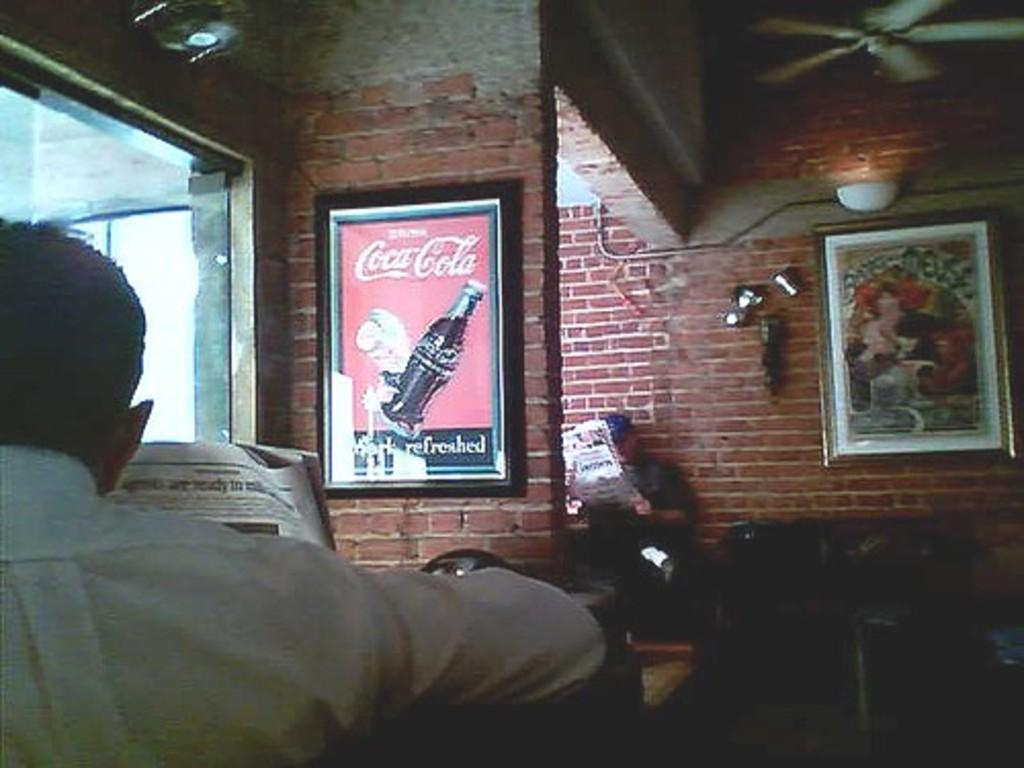What type of structure can be seen in the image? There are walls in the image, suggesting a room or building. What is hanging on the walls in the image? There are pictures on the walls in the image. What can be seen for cooling purposes in the image? There is a fan in the image. Who or what is present in the image? There are people in the image. What type of reading material is visible in the image? There are newspapers in the image. What allows natural light to enter the room in the image? There is a glass window in the image. Can you describe any other objects in the image? There are unspecified objects in the image. How many cows can be seen grazing in the image? There are no cows present in the image. What type of bone is being used as a decoration in the image? There is no bone present in the image. 